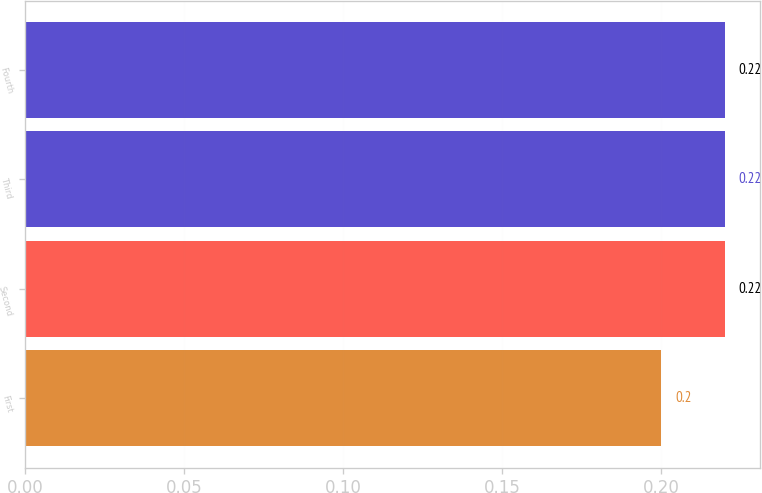<chart> <loc_0><loc_0><loc_500><loc_500><bar_chart><fcel>First<fcel>Second<fcel>Third<fcel>Fourth<nl><fcel>0.2<fcel>0.22<fcel>0.22<fcel>0.22<nl></chart> 